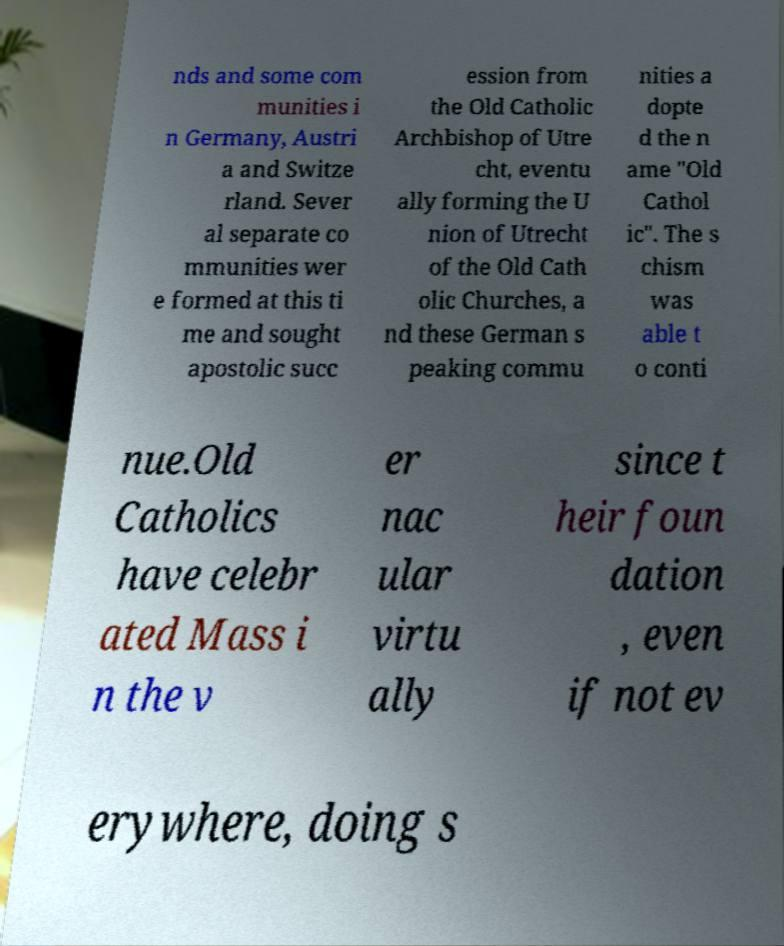Can you read and provide the text displayed in the image?This photo seems to have some interesting text. Can you extract and type it out for me? nds and some com munities i n Germany, Austri a and Switze rland. Sever al separate co mmunities wer e formed at this ti me and sought apostolic succ ession from the Old Catholic Archbishop of Utre cht, eventu ally forming the U nion of Utrecht of the Old Cath olic Churches, a nd these German s peaking commu nities a dopte d the n ame "Old Cathol ic". The s chism was able t o conti nue.Old Catholics have celebr ated Mass i n the v er nac ular virtu ally since t heir foun dation , even if not ev erywhere, doing s 